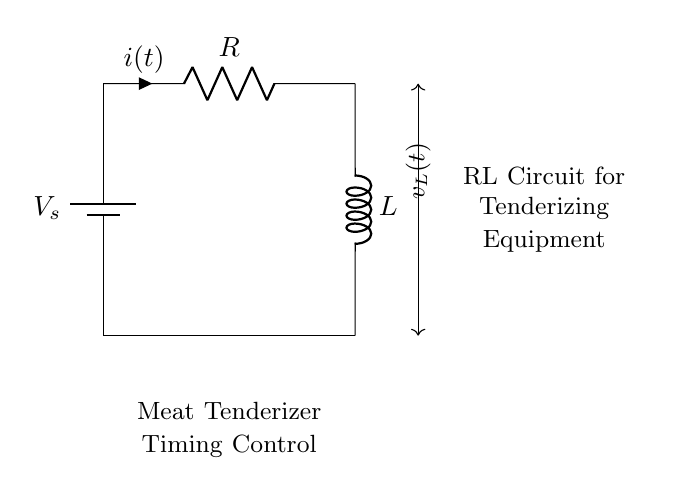What components are in the circuit? The circuit contains a resistor and an inductor, both essential for its function. The resistor (R) limits current, and the inductor (L) stores energy in a magnetic field.
Answer: Resistor and inductor What is the function of the resistor in this circuit? The resistor limits the current flowing through the circuit, which is crucial for controlling the circuit's timing and ensuring that the meat tenderizer operates safely and effectively.
Answer: Current limiting What is the purpose of the inductor in this circuit? The inductor stores energy in a magnetic field when current passes through it. This characteristic is used in timing applications to create a delay in the current buildup, essential for the meat tenderizing process.
Answer: Energy storage What is the relationship between voltage and current in this circuit? In this RL circuit, the voltage across the inductor (v_L) relates to the rate of change of current. According to Kirchhoff's law, the source voltage (V_s) equals the sum of the voltage drop across the resistor and the inductor.
Answer: V_s = v_R + v_L What is the expected effect of increasing the resistor value on timing control? Increasing the resistor value would slow down the rate of current change in the circuit, which means it would take longer for the inductor to reach its maximum current. This results in a longer timing control for the meat tenderizer operation.
Answer: Longer timing control What type of circuit is represented here? This is a resistor-inductor (RL) circuit, which is specifically used for timing control. The combination of resistor and inductor allows for the delayed response necessary in the application for meat tenderizing equipment.
Answer: RL circuit 